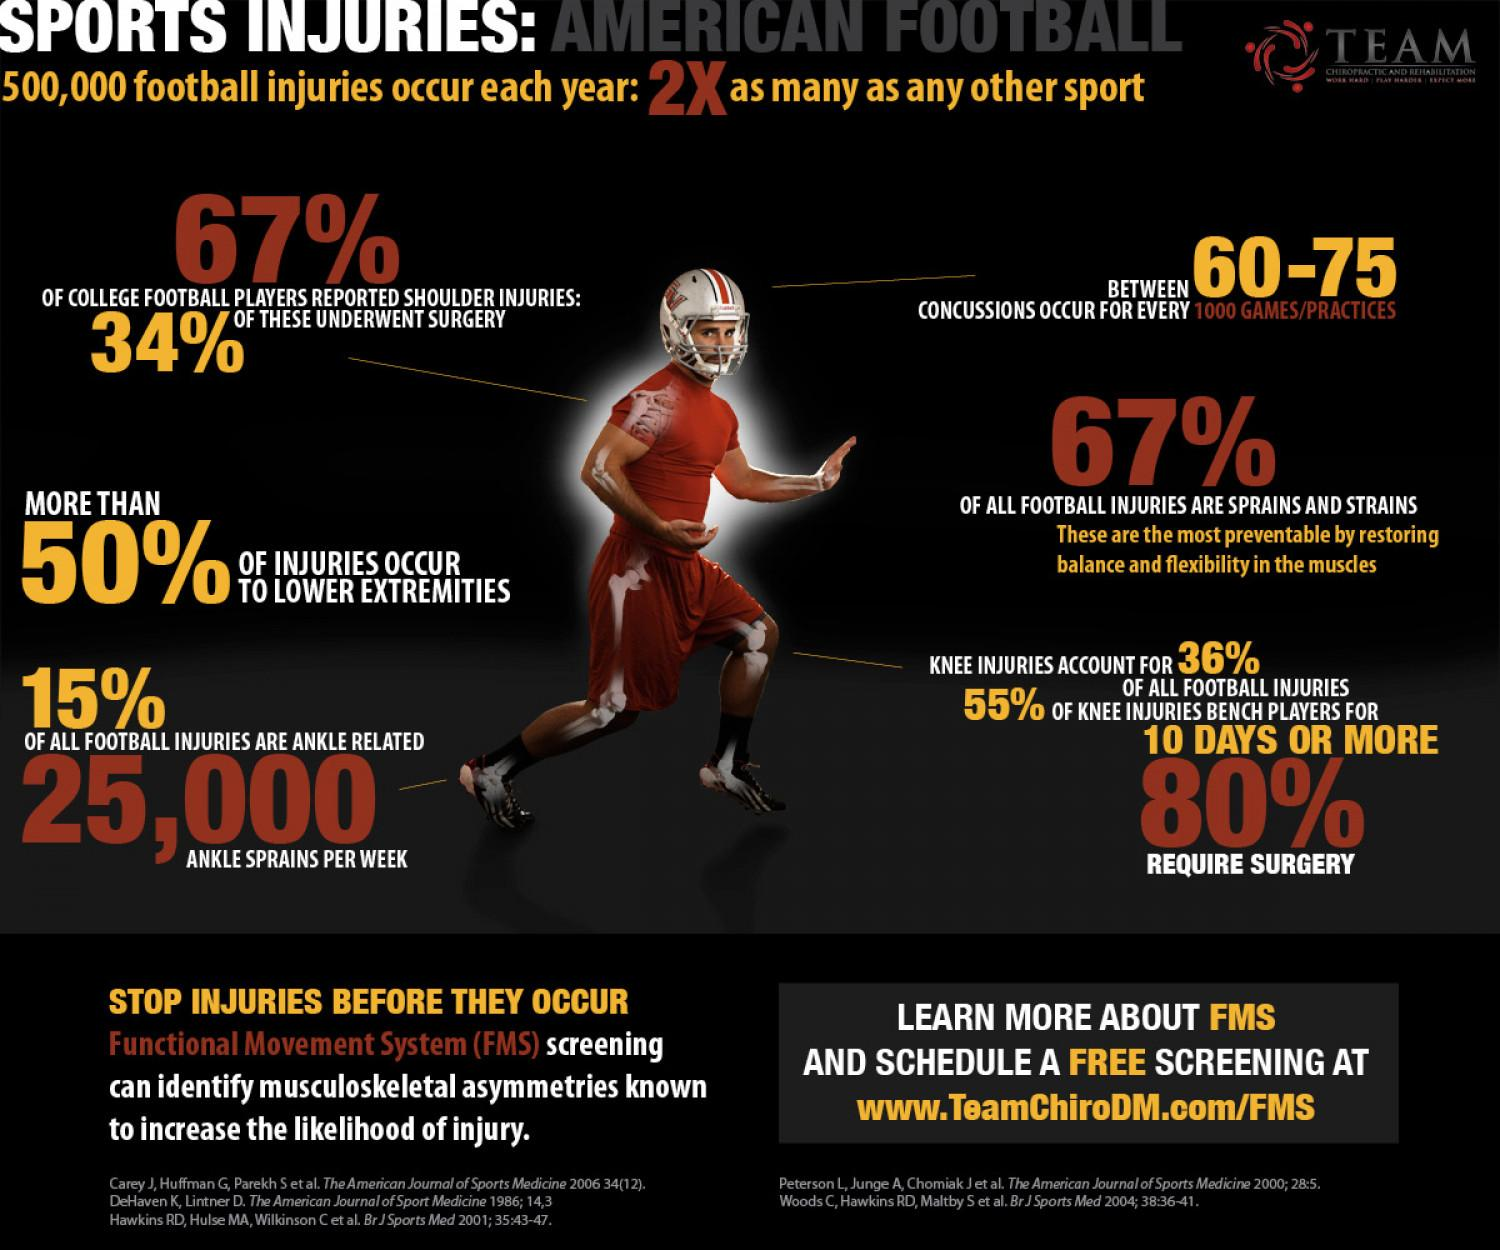Give some essential details in this illustration. The majority of injuries occur in the lower extremities. 